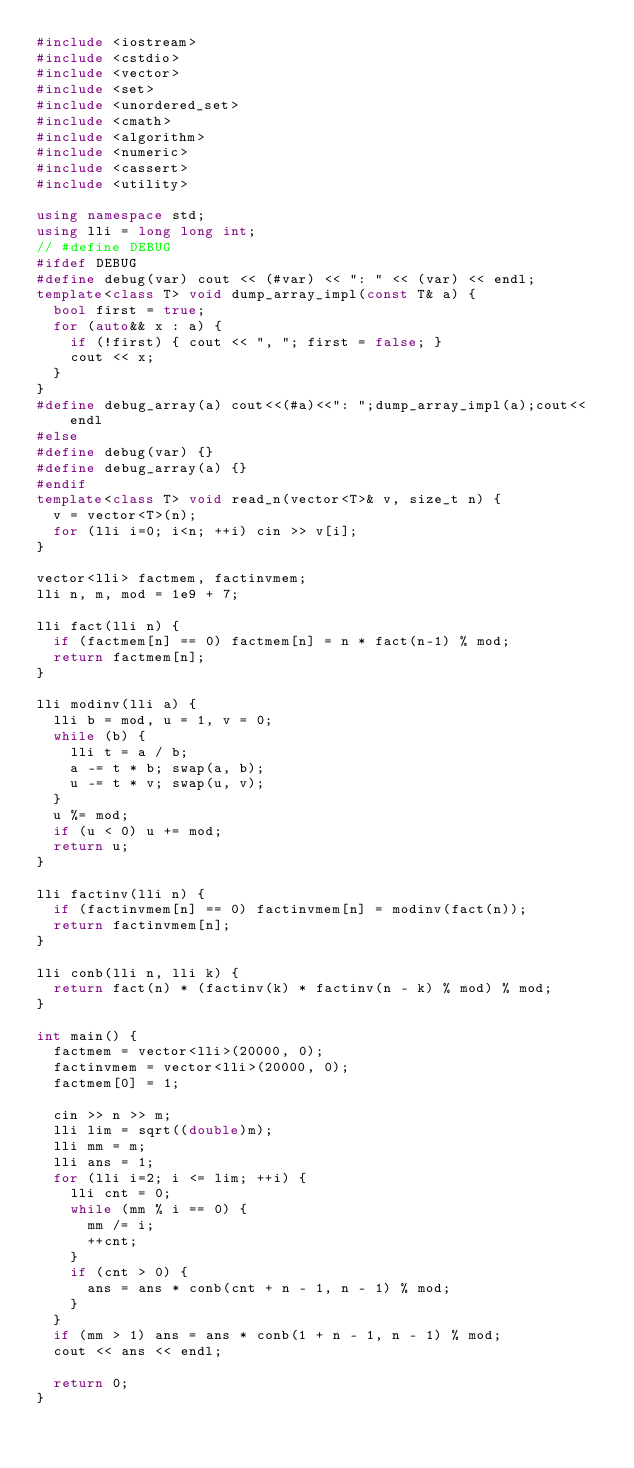Convert code to text. <code><loc_0><loc_0><loc_500><loc_500><_C++_>#include <iostream>
#include <cstdio>
#include <vector>
#include <set>
#include <unordered_set>
#include <cmath>
#include <algorithm>
#include <numeric>
#include <cassert>
#include <utility>

using namespace std;
using lli = long long int;
// #define DEBUG
#ifdef DEBUG
#define debug(var) cout << (#var) << ": " << (var) << endl;
template<class T> void dump_array_impl(const T& a) {
  bool first = true;
  for (auto&& x : a) {
    if (!first) { cout << ", "; first = false; }
    cout << x;
  }
}
#define debug_array(a) cout<<(#a)<<": ";dump_array_impl(a);cout<<endl
#else
#define debug(var) {}
#define debug_array(a) {}
#endif
template<class T> void read_n(vector<T>& v, size_t n) {
  v = vector<T>(n);
  for (lli i=0; i<n; ++i) cin >> v[i];
}

vector<lli> factmem, factinvmem;
lli n, m, mod = 1e9 + 7;

lli fact(lli n) {
  if (factmem[n] == 0) factmem[n] = n * fact(n-1) % mod;
  return factmem[n];
}

lli modinv(lli a) {
  lli b = mod, u = 1, v = 0;
  while (b) {
    lli t = a / b;
    a -= t * b; swap(a, b);
    u -= t * v; swap(u, v);
  }
  u %= mod;
  if (u < 0) u += mod;
  return u;
}

lli factinv(lli n) {
  if (factinvmem[n] == 0) factinvmem[n] = modinv(fact(n));
  return factinvmem[n];
}

lli conb(lli n, lli k) {
  return fact(n) * (factinv(k) * factinv(n - k) % mod) % mod;
}

int main() {
  factmem = vector<lli>(20000, 0);
  factinvmem = vector<lli>(20000, 0);
  factmem[0] = 1;

  cin >> n >> m;
  lli lim = sqrt((double)m);
  lli mm = m;
  lli ans = 1;
  for (lli i=2; i <= lim; ++i) {
    lli cnt = 0;
    while (mm % i == 0) {
      mm /= i;
      ++cnt;
    }
    if (cnt > 0) {
      ans = ans * conb(cnt + n - 1, n - 1) % mod;
    }
  }
  if (mm > 1) ans = ans * conb(1 + n - 1, n - 1) % mod;
  cout << ans << endl;
  
  return 0;
}
</code> 